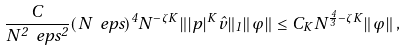Convert formula to latex. <formula><loc_0><loc_0><loc_500><loc_500>\frac { C } { N ^ { 2 } \ e p s ^ { 2 } } ( N \ e p s ) ^ { 4 } N ^ { - \zeta K } \| | p | ^ { K } \hat { v } \| _ { 1 } \| \varphi \| \leq C _ { K } N ^ { \frac { 4 } { 3 } - \zeta K } \| \varphi \| \, ,</formula> 